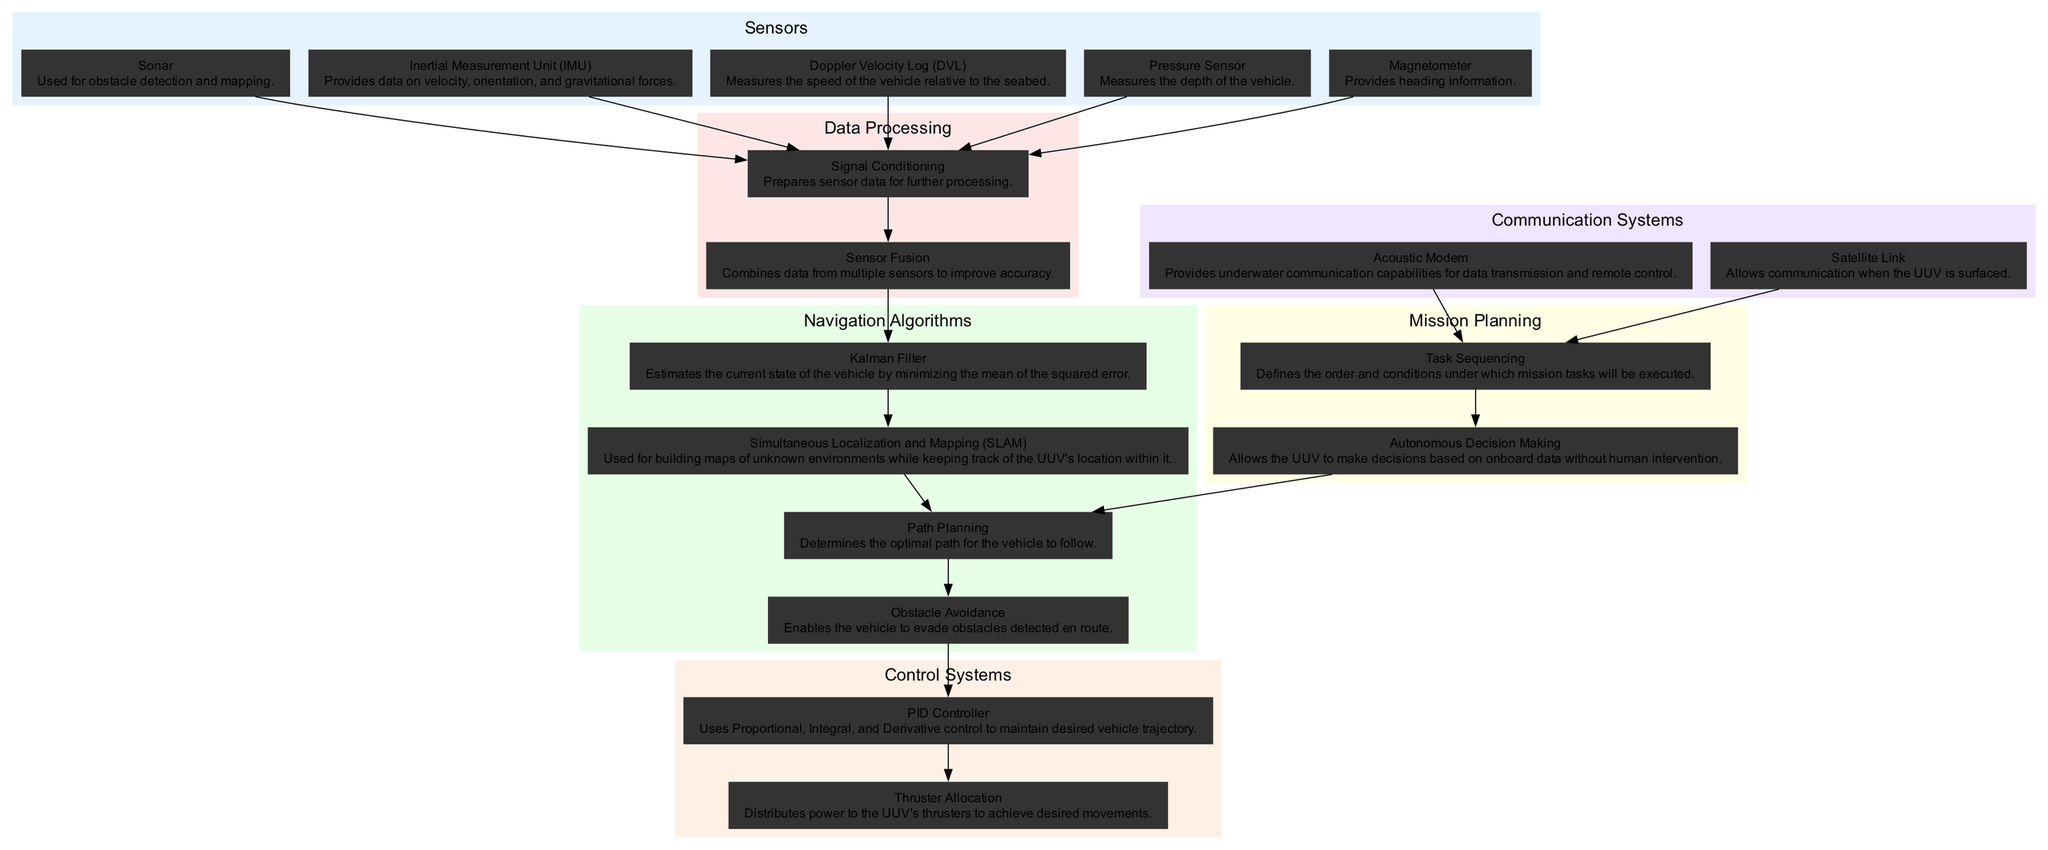What is the first sensor listed in the diagram? The first sensor in the list is "Sonar," as it appears at the top of the "Sensors" category in the diagram.
Answer: Sonar How many sensors are there in total? There are five sensors listed in the "Sensors" category: Sonar, Inertial Measurement Unit, Doppler Velocity Log, Pressure Sensor, and Magnetometer.
Answer: Five Which data processing step follows "Signal Conditioning"? The data processing step that follows "Signal Conditioning" is "Sensor Fusion," which receives the conditioned data from the sensors.
Answer: Sensor Fusion What is the relationship between "Obstacle Avoidance" and "PID Controller"? "Obstacle Avoidance" directly connects to "PID Controller," indicating that the output of the obstacle avoidance algorithm influences the control process managed by the PID Controller.
Answer: Direct connection Which navigation algorithm is utilized for building maps of unknown environments? The navigation algorithm used for building maps of unknown environments is "Simultaneous Localization and Mapping," as indicated in the navigation algorithms section.
Answer: Simultaneous Localization and Mapping How does "Path Planning" relate to "Autonomous Decision Making"? "Path Planning" is influenced by "Autonomous Decision Making," which allows the UUV to decide on the optimal path based on its mission tasks, indicating its role in determining the movement strategy.
Answer: Influenced by What type of communication is enabled when the UUV is surfaced? The communication type that is enabled when the UUV is surfaced is via "Satellite Link," which allows for data transmission when not underwater.
Answer: Satellite Link How many main categories of elements are there in the diagram? There are six main categories of elements in the diagram: Sensors, Data Processing, Navigation Algorithms, Control Systems, Communication Systems, and Mission Planning.
Answer: Six What system distributes power to the UUV's thrusters? The system responsible for distributing power to the UUV's thrusters is called "Thruster Allocation," which follows the PID Controller in the control systems section.
Answer: Thruster Allocation 